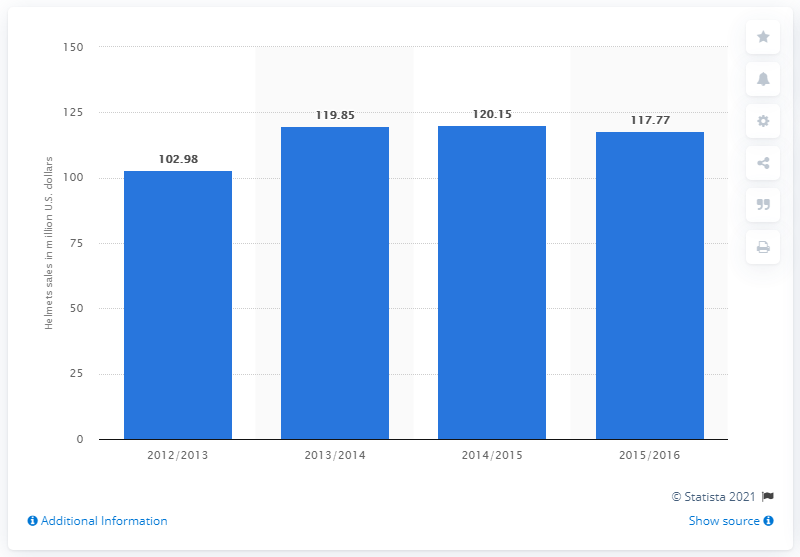Point out several critical features in this image. In the United States, snow sports helmet sales totaled 117.77 million dollars in 2015/16. 